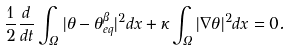<formula> <loc_0><loc_0><loc_500><loc_500>\frac { 1 } { 2 } \frac { d } { d t } \int _ { \Omega } | \theta - \theta _ { e q } ^ { \beta } | ^ { 2 } d x + \kappa \int _ { \Omega } | \nabla \theta | ^ { 2 } d x = 0 .</formula> 